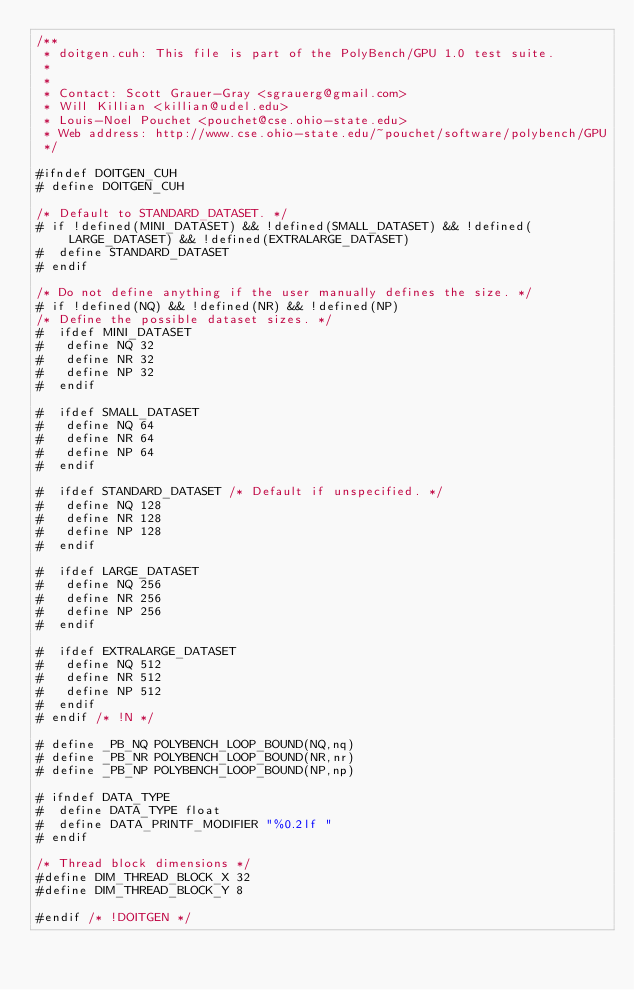Convert code to text. <code><loc_0><loc_0><loc_500><loc_500><_Cuda_>/**
 * doitgen.cuh: This file is part of the PolyBench/GPU 1.0 test suite.
 *
 *
 * Contact: Scott Grauer-Gray <sgrauerg@gmail.com>
 * Will Killian <killian@udel.edu>
 * Louis-Noel Pouchet <pouchet@cse.ohio-state.edu>
 * Web address: http://www.cse.ohio-state.edu/~pouchet/software/polybench/GPU
 */

#ifndef DOITGEN_CUH
# define DOITGEN_CUH

/* Default to STANDARD_DATASET. */
# if !defined(MINI_DATASET) && !defined(SMALL_DATASET) && !defined(LARGE_DATASET) && !defined(EXTRALARGE_DATASET)
#  define STANDARD_DATASET
# endif

/* Do not define anything if the user manually defines the size. */
# if !defined(NQ) && !defined(NR) && !defined(NP)
/* Define the possible dataset sizes. */
#  ifdef MINI_DATASET
#   define NQ 32
#   define NR 32
#   define NP 32
#  endif

#  ifdef SMALL_DATASET
#   define NQ 64
#   define NR 64
#   define NP 64
#  endif

#  ifdef STANDARD_DATASET /* Default if unspecified. */
#   define NQ 128
#   define NR 128
#   define NP 128
#  endif

#  ifdef LARGE_DATASET
#   define NQ 256
#   define NR 256
#   define NP 256
#  endif

#  ifdef EXTRALARGE_DATASET
#   define NQ 512
#   define NR 512
#   define NP 512
#  endif
# endif /* !N */

# define _PB_NQ POLYBENCH_LOOP_BOUND(NQ,nq)
# define _PB_NR POLYBENCH_LOOP_BOUND(NR,nr)
# define _PB_NP POLYBENCH_LOOP_BOUND(NP,np)

# ifndef DATA_TYPE
#  define DATA_TYPE float
#  define DATA_PRINTF_MODIFIER "%0.2lf "
# endif

/* Thread block dimensions */
#define DIM_THREAD_BLOCK_X 32
#define DIM_THREAD_BLOCK_Y 8

#endif /* !DOITGEN */
</code> 